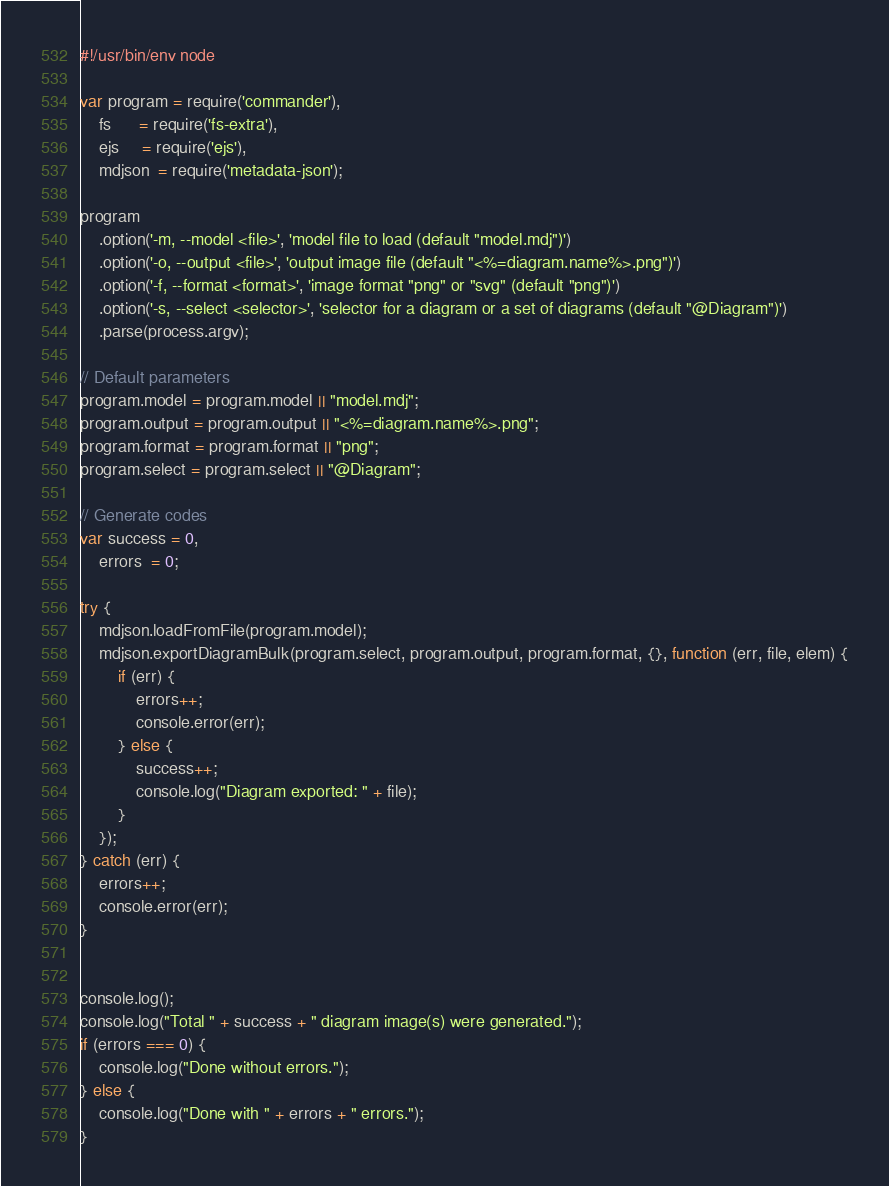Convert code to text. <code><loc_0><loc_0><loc_500><loc_500><_JavaScript_>#!/usr/bin/env node

var program = require('commander'),
    fs      = require('fs-extra'),
    ejs     = require('ejs'),
    mdjson  = require('metadata-json');

program
    .option('-m, --model <file>', 'model file to load (default "model.mdj")')
    .option('-o, --output <file>', 'output image file (default "<%=diagram.name%>.png")')
    .option('-f, --format <format>', 'image format "png" or "svg" (default "png")')
    .option('-s, --select <selector>', 'selector for a diagram or a set of diagrams (default "@Diagram")')
    .parse(process.argv);

// Default parameters
program.model = program.model || "model.mdj";
program.output = program.output || "<%=diagram.name%>.png";
program.format = program.format || "png";
program.select = program.select || "@Diagram";

// Generate codes
var success = 0,
    errors  = 0;

try {
    mdjson.loadFromFile(program.model);
    mdjson.exportDiagramBulk(program.select, program.output, program.format, {}, function (err, file, elem) {
        if (err) {
            errors++;
            console.error(err);
        } else {
            success++;
            console.log("Diagram exported: " + file);
        }
    });
} catch (err) {
    errors++;
    console.error(err);
}


console.log();
console.log("Total " + success + " diagram image(s) were generated.");
if (errors === 0) {
    console.log("Done without errors.");
} else {
    console.log("Done with " + errors + " errors.");
}
</code> 